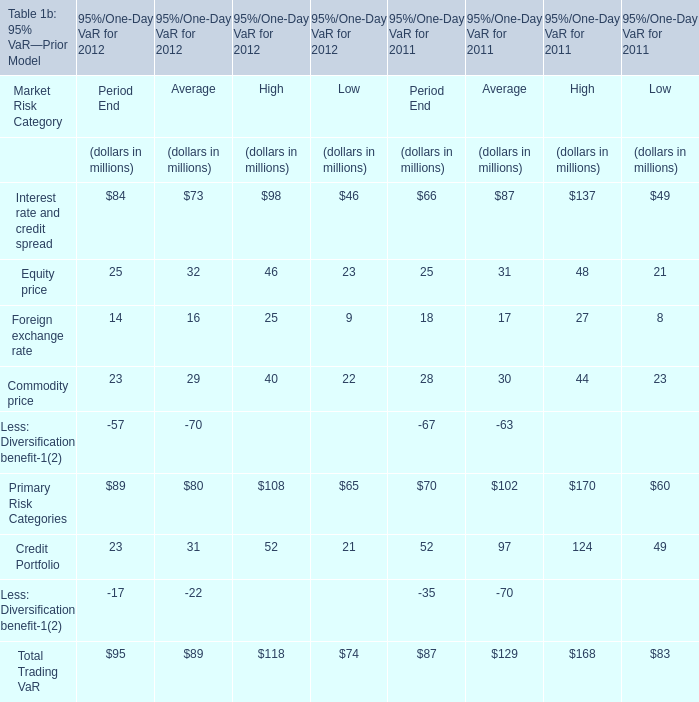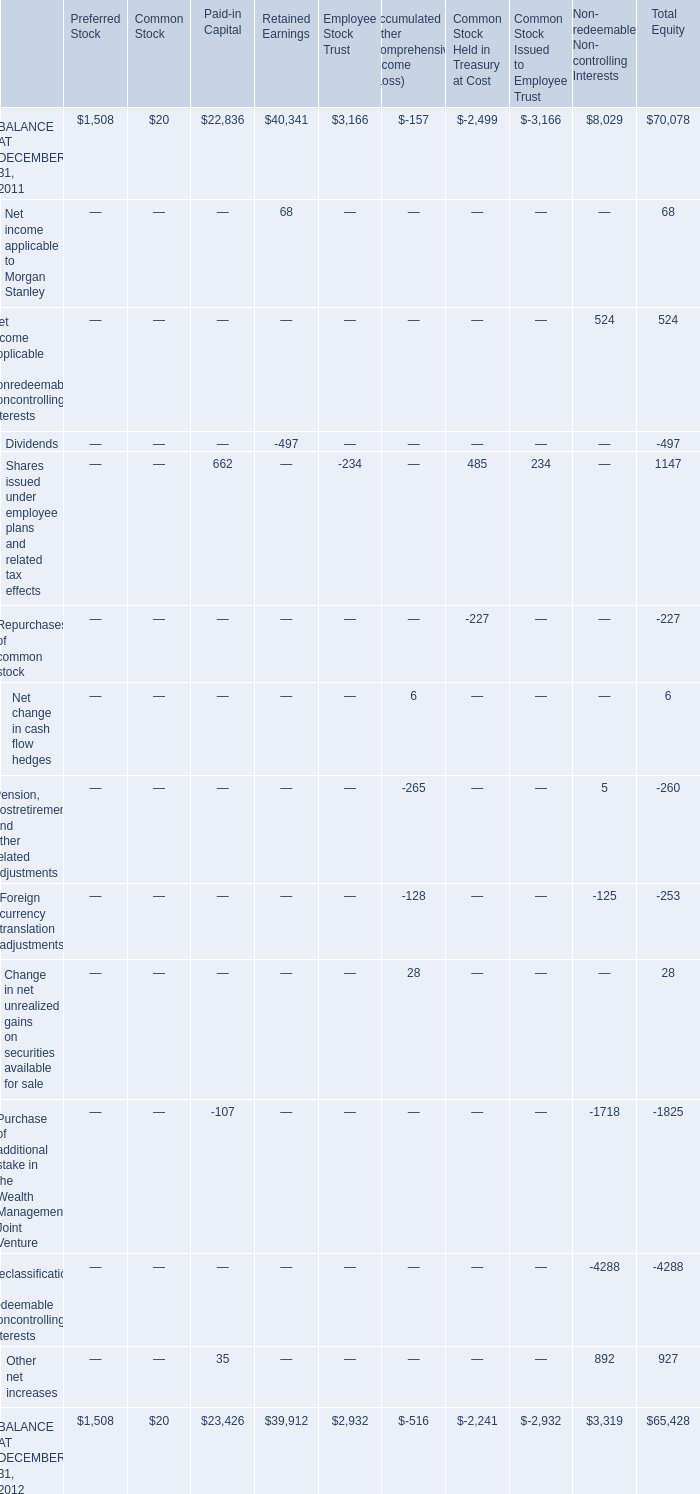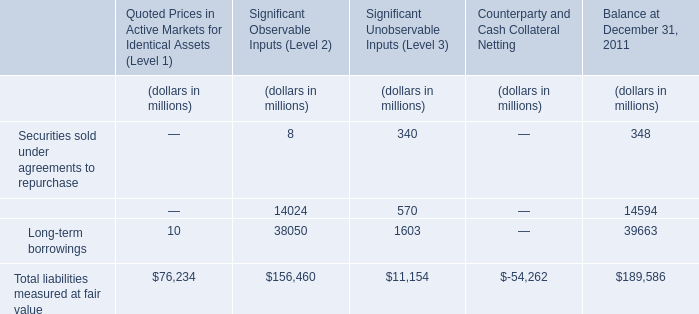What's the current growth rate of Primary Risk Categories for Period End? 
Computations: ((89 - 70) / 70)
Answer: 0.27143. 